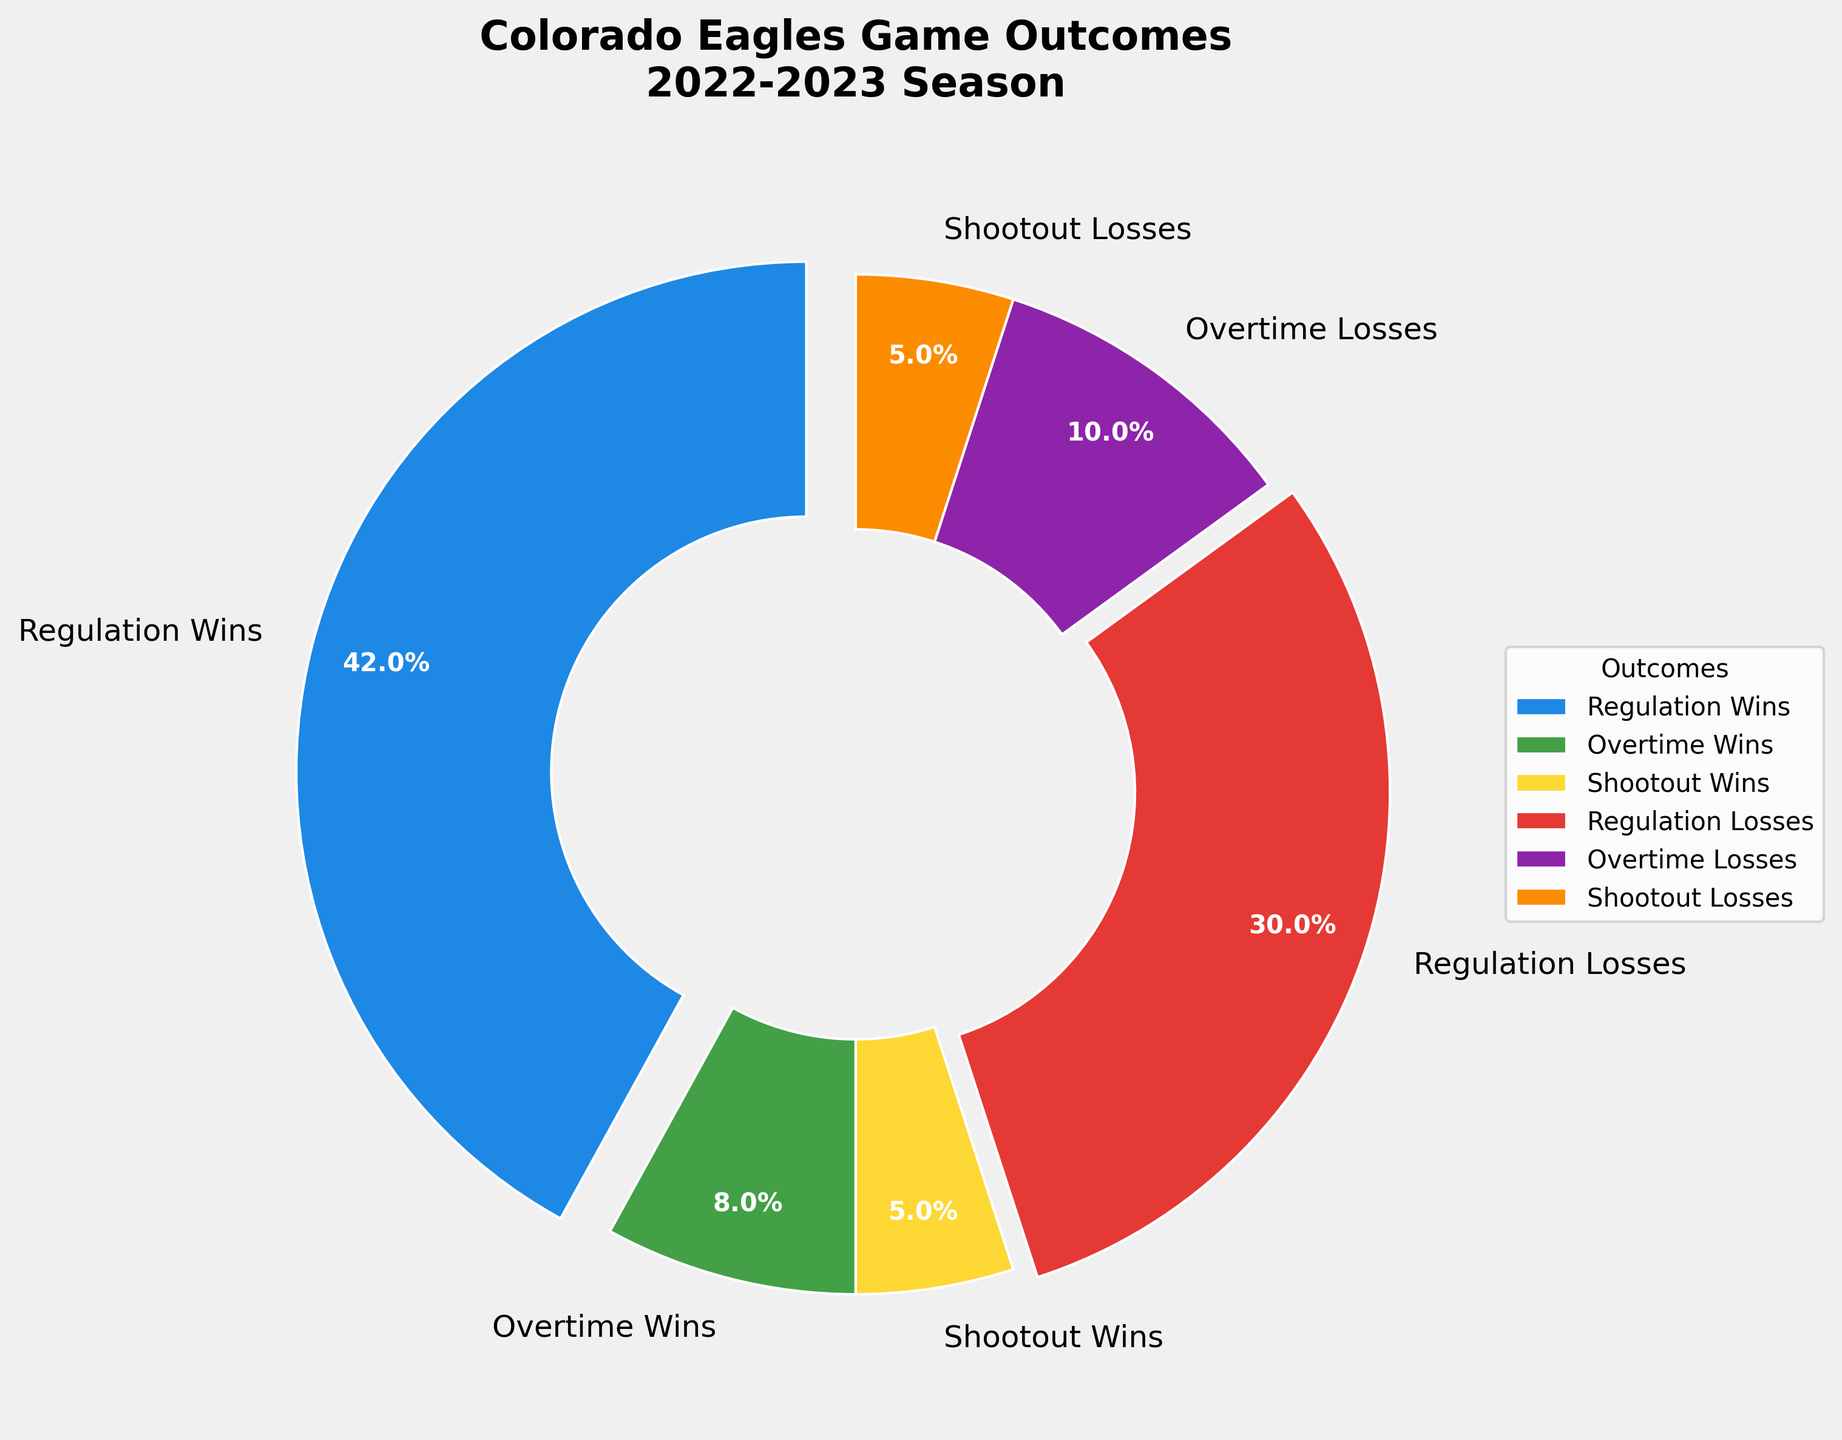What is the percentage of games the Colorado Eagles won in the 2022-2023 season? Add the percentages of Regulation Wins, Overtime Wins, and Shootout Wins, which are 42%, 8%, and 5% respectively. 42% + 8% + 5% = 55%
Answer: 55% Which outcome had the highest percentage in the Colorado Eagles' 2022-2023 season? The highest percentage can be seen for the Regulation Wins slice, which is 42%.
Answer: Regulation Wins How does the percentage of Overtime Losses compare to Shootout Losses? The percentage of Overtime Losses is 10%, which can be seen in its respective slice, while Shootout Losses have a percentage of 5%. Overtime Losses (10%) are higher than Shootout Losses (5%).
Answer: Overtime Losses are higher What is the combined percentage of games that ended in either an Overtime or Shootout? Sum up the percentages of Overtime Wins, Shootout Wins, Overtime Losses, and Shootout Losses. So, it is 8% + 5% + 10% + 5% = 28%
Answer: 28% What visual attributes help identify the Regulation Wins slice in the pie chart? The slice for Regulation Wins is visually distinct because it is larger in size compared to others and slightly exploded from the center, making it stand out. Additionally, it is labeled with 42%.
Answer: It’s larger and slightly exploded What proportion of the losses happened outside of regulation time? To find the proportion of losses outside of regulation, combine the Overtime Losses (10%) and Shootout Losses (5%). So, the total is 10% + 5% = 15%.
Answer: 15% What is the difference between the percentages of Regulation Wins and Regulation Losses? Regulation Wins have a percentage of 42%, and Regulation Losses have a percentage of 30%. The difference is 42% - 30% = 12%.
Answer: 12% Which color represents the Overtime Wins, and what is their percentage? The Overtime Wins slice is colored green and has a percentage noted as 8%.
Answer: Green, 8% What is the ratio of Overtime Wins to Overtime Losses? The percentages for Overtime Wins and Overtime Losses are 8% and 10% respectively. The ratio 8/10 simplifies to 4/5.
Answer: 4:5 